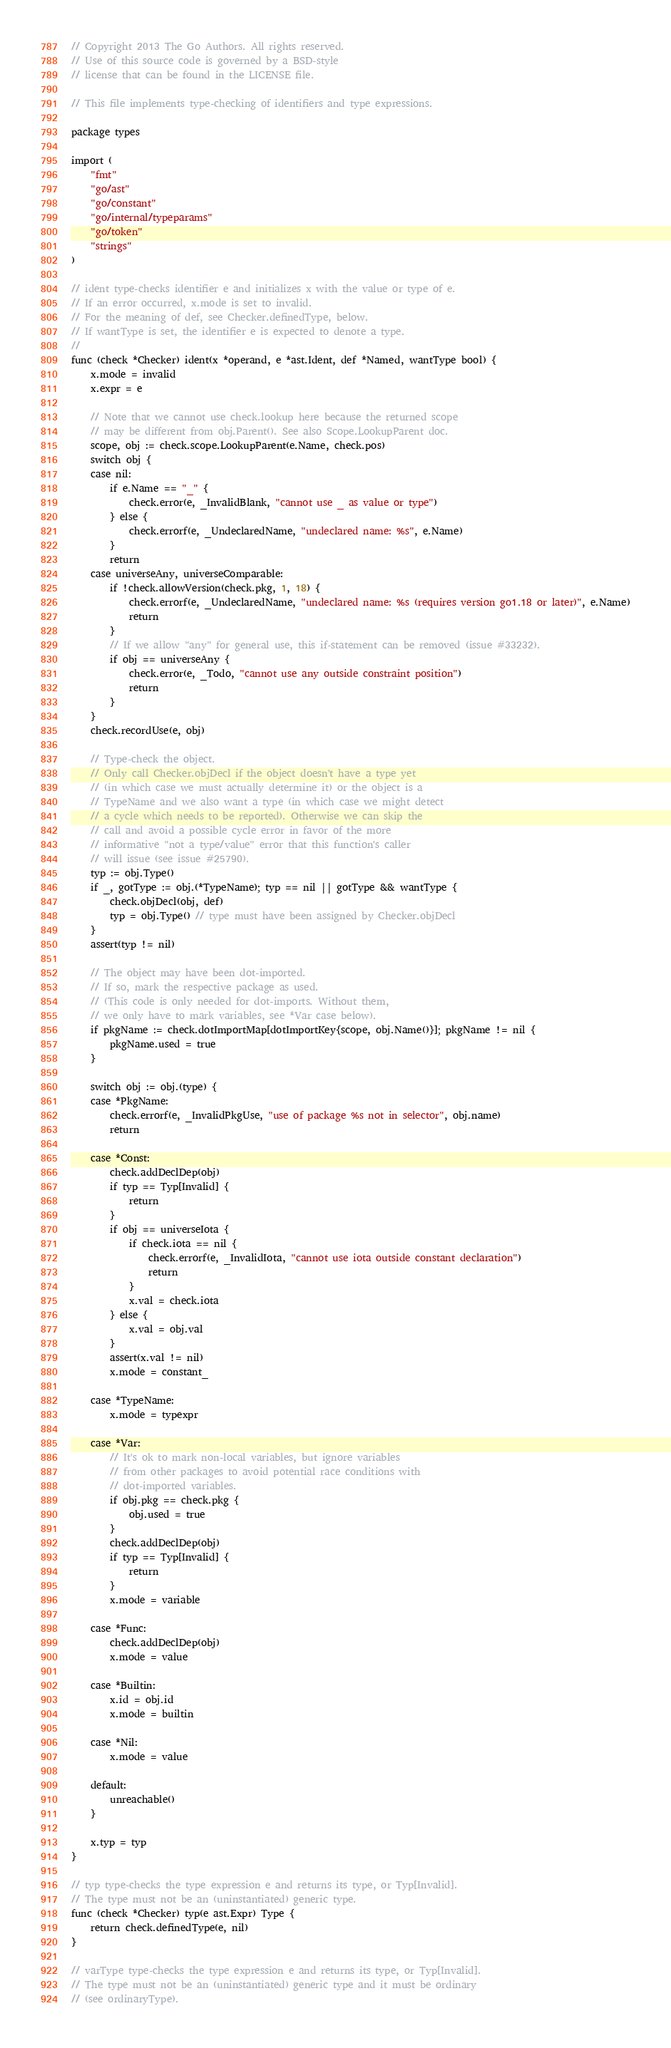<code> <loc_0><loc_0><loc_500><loc_500><_Go_>// Copyright 2013 The Go Authors. All rights reserved.
// Use of this source code is governed by a BSD-style
// license that can be found in the LICENSE file.

// This file implements type-checking of identifiers and type expressions.

package types

import (
	"fmt"
	"go/ast"
	"go/constant"
	"go/internal/typeparams"
	"go/token"
	"strings"
)

// ident type-checks identifier e and initializes x with the value or type of e.
// If an error occurred, x.mode is set to invalid.
// For the meaning of def, see Checker.definedType, below.
// If wantType is set, the identifier e is expected to denote a type.
//
func (check *Checker) ident(x *operand, e *ast.Ident, def *Named, wantType bool) {
	x.mode = invalid
	x.expr = e

	// Note that we cannot use check.lookup here because the returned scope
	// may be different from obj.Parent(). See also Scope.LookupParent doc.
	scope, obj := check.scope.LookupParent(e.Name, check.pos)
	switch obj {
	case nil:
		if e.Name == "_" {
			check.error(e, _InvalidBlank, "cannot use _ as value or type")
		} else {
			check.errorf(e, _UndeclaredName, "undeclared name: %s", e.Name)
		}
		return
	case universeAny, universeComparable:
		if !check.allowVersion(check.pkg, 1, 18) {
			check.errorf(e, _UndeclaredName, "undeclared name: %s (requires version go1.18 or later)", e.Name)
			return
		}
		// If we allow "any" for general use, this if-statement can be removed (issue #33232).
		if obj == universeAny {
			check.error(e, _Todo, "cannot use any outside constraint position")
			return
		}
	}
	check.recordUse(e, obj)

	// Type-check the object.
	// Only call Checker.objDecl if the object doesn't have a type yet
	// (in which case we must actually determine it) or the object is a
	// TypeName and we also want a type (in which case we might detect
	// a cycle which needs to be reported). Otherwise we can skip the
	// call and avoid a possible cycle error in favor of the more
	// informative "not a type/value" error that this function's caller
	// will issue (see issue #25790).
	typ := obj.Type()
	if _, gotType := obj.(*TypeName); typ == nil || gotType && wantType {
		check.objDecl(obj, def)
		typ = obj.Type() // type must have been assigned by Checker.objDecl
	}
	assert(typ != nil)

	// The object may have been dot-imported.
	// If so, mark the respective package as used.
	// (This code is only needed for dot-imports. Without them,
	// we only have to mark variables, see *Var case below).
	if pkgName := check.dotImportMap[dotImportKey{scope, obj.Name()}]; pkgName != nil {
		pkgName.used = true
	}

	switch obj := obj.(type) {
	case *PkgName:
		check.errorf(e, _InvalidPkgUse, "use of package %s not in selector", obj.name)
		return

	case *Const:
		check.addDeclDep(obj)
		if typ == Typ[Invalid] {
			return
		}
		if obj == universeIota {
			if check.iota == nil {
				check.errorf(e, _InvalidIota, "cannot use iota outside constant declaration")
				return
			}
			x.val = check.iota
		} else {
			x.val = obj.val
		}
		assert(x.val != nil)
		x.mode = constant_

	case *TypeName:
		x.mode = typexpr

	case *Var:
		// It's ok to mark non-local variables, but ignore variables
		// from other packages to avoid potential race conditions with
		// dot-imported variables.
		if obj.pkg == check.pkg {
			obj.used = true
		}
		check.addDeclDep(obj)
		if typ == Typ[Invalid] {
			return
		}
		x.mode = variable

	case *Func:
		check.addDeclDep(obj)
		x.mode = value

	case *Builtin:
		x.id = obj.id
		x.mode = builtin

	case *Nil:
		x.mode = value

	default:
		unreachable()
	}

	x.typ = typ
}

// typ type-checks the type expression e and returns its type, or Typ[Invalid].
// The type must not be an (uninstantiated) generic type.
func (check *Checker) typ(e ast.Expr) Type {
	return check.definedType(e, nil)
}

// varType type-checks the type expression e and returns its type, or Typ[Invalid].
// The type must not be an (uninstantiated) generic type and it must be ordinary
// (see ordinaryType).</code> 